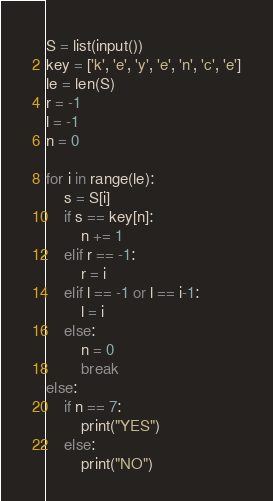Convert code to text. <code><loc_0><loc_0><loc_500><loc_500><_Python_>S = list(input())
key = ['k', 'e', 'y', 'e', 'n', 'c', 'e']
le = len(S)
r = -1
l = -1
n = 0

for i in range(le):
    s = S[i]
    if s == key[n]:
        n += 1
    elif r == -1:
        r = i
    elif l == -1 or l == i-1:
        l = i
    else:
        n = 0
        break
else:
    if n == 7:
        print("YES")
    else:
        print("NO")
</code> 